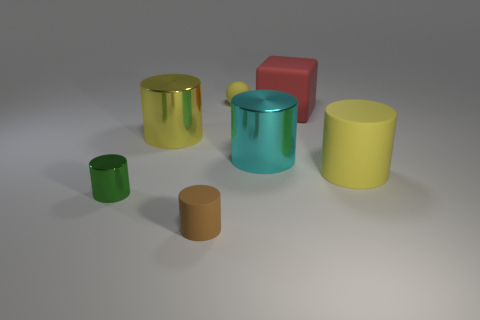Subtract 2 cylinders. How many cylinders are left? 3 Subtract all brown cylinders. How many cylinders are left? 4 Subtract all green metallic cylinders. How many cylinders are left? 4 Subtract all red cylinders. Subtract all cyan spheres. How many cylinders are left? 5 Add 3 big red matte blocks. How many objects exist? 10 Subtract all cylinders. How many objects are left? 2 Subtract 0 gray balls. How many objects are left? 7 Subtract all big yellow matte things. Subtract all yellow things. How many objects are left? 3 Add 5 red objects. How many red objects are left? 6 Add 4 yellow metallic objects. How many yellow metallic objects exist? 5 